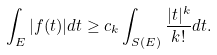<formula> <loc_0><loc_0><loc_500><loc_500>\int _ { E } | f ( t ) | d t \geq c _ { k } \int _ { S ( E ) } \frac { | t | ^ { k } } { k ! } d t .</formula> 